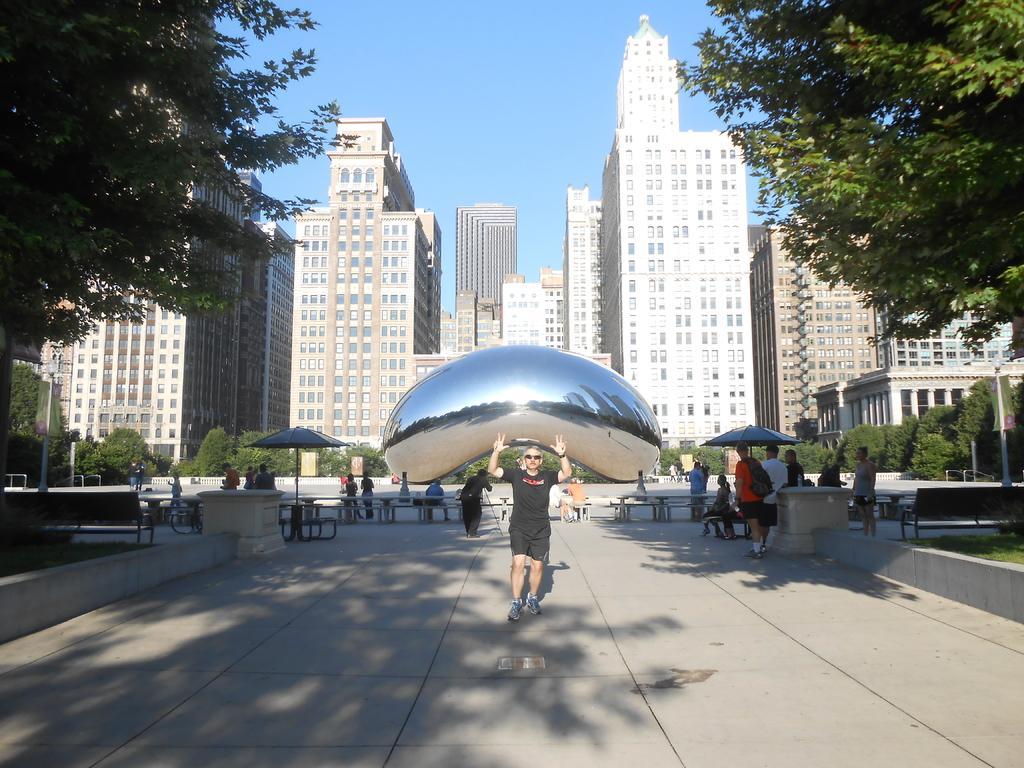Describe this image in one or two sentences. In the center of the image we can see one person is standing and he is holding some object. In the background, we can see the sky, buildings, trees, outdoor umbrellas, benches, few people and a few other objects. 